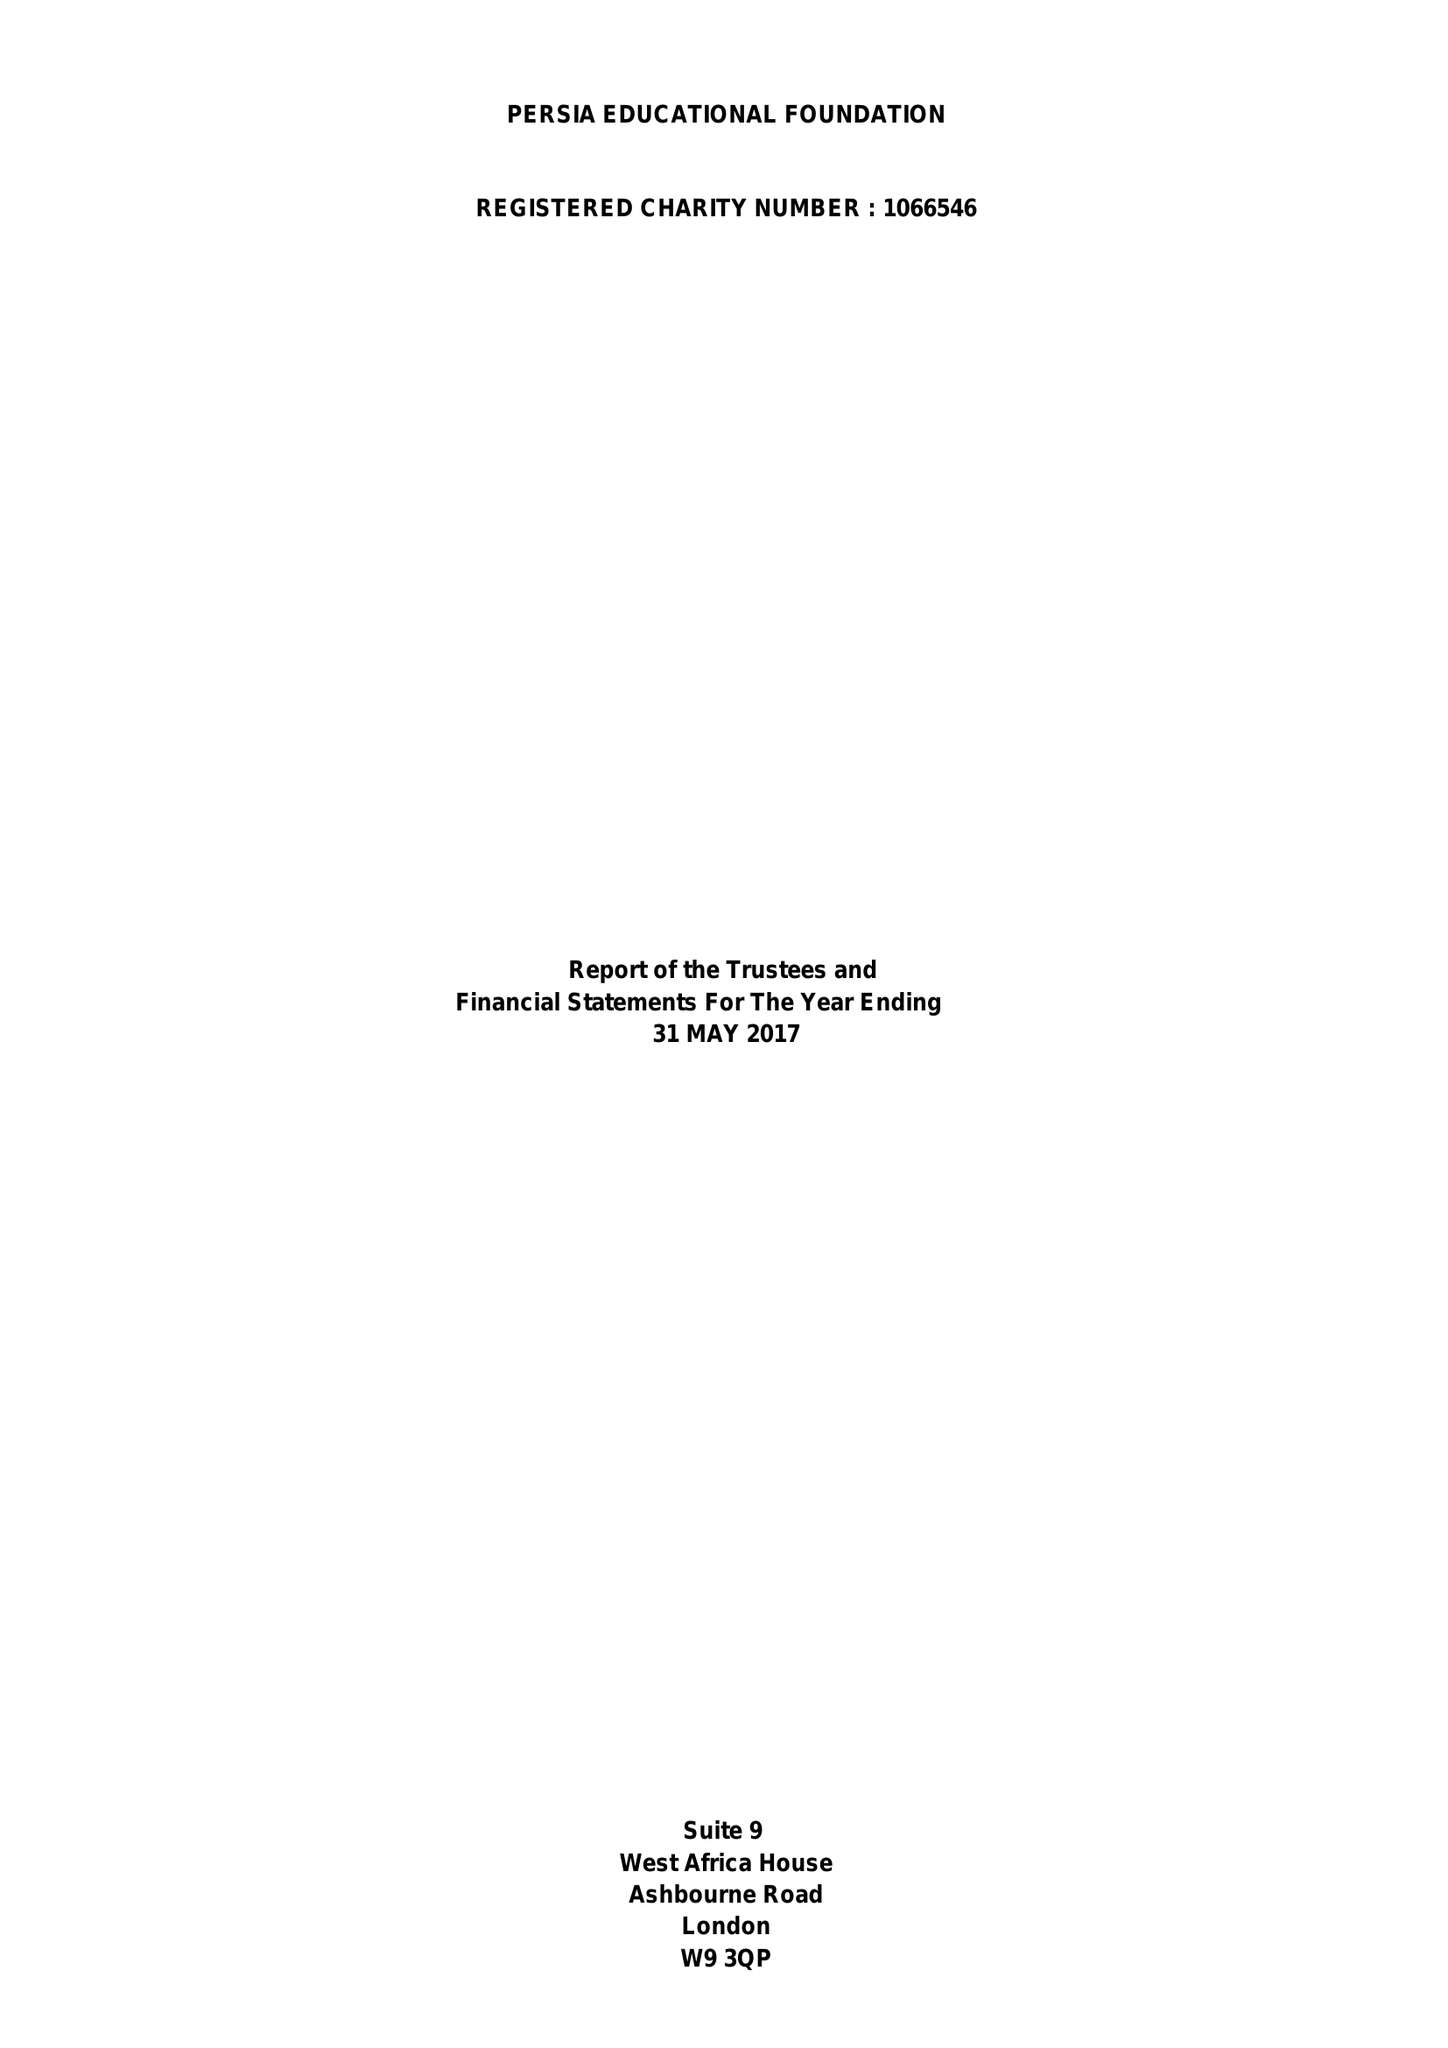What is the value for the spending_annually_in_british_pounds?
Answer the question using a single word or phrase. 39490.00 